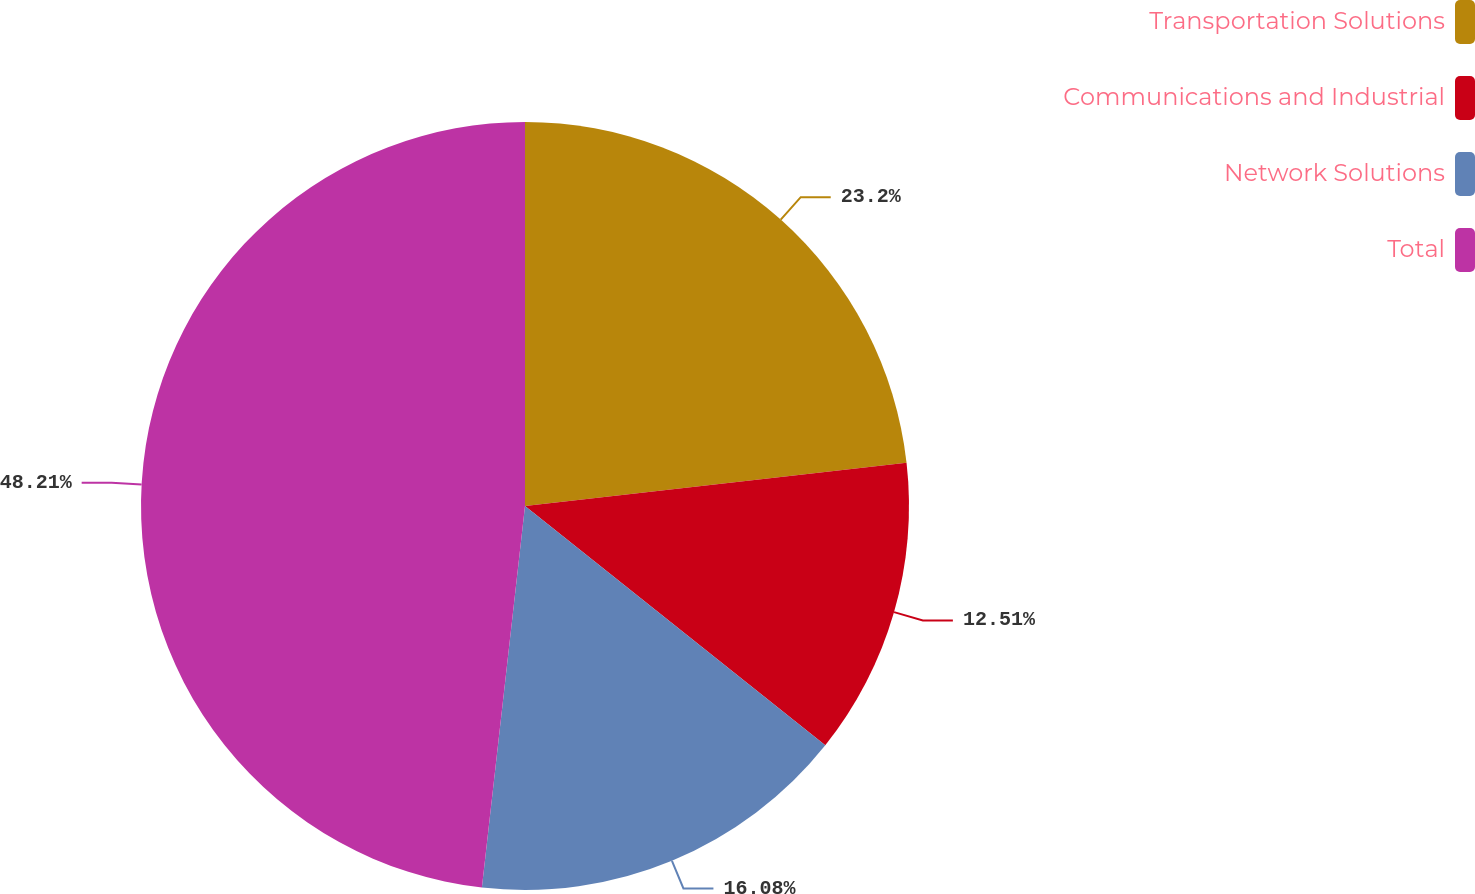Convert chart. <chart><loc_0><loc_0><loc_500><loc_500><pie_chart><fcel>Transportation Solutions<fcel>Communications and Industrial<fcel>Network Solutions<fcel>Total<nl><fcel>23.2%<fcel>12.51%<fcel>16.08%<fcel>48.21%<nl></chart> 